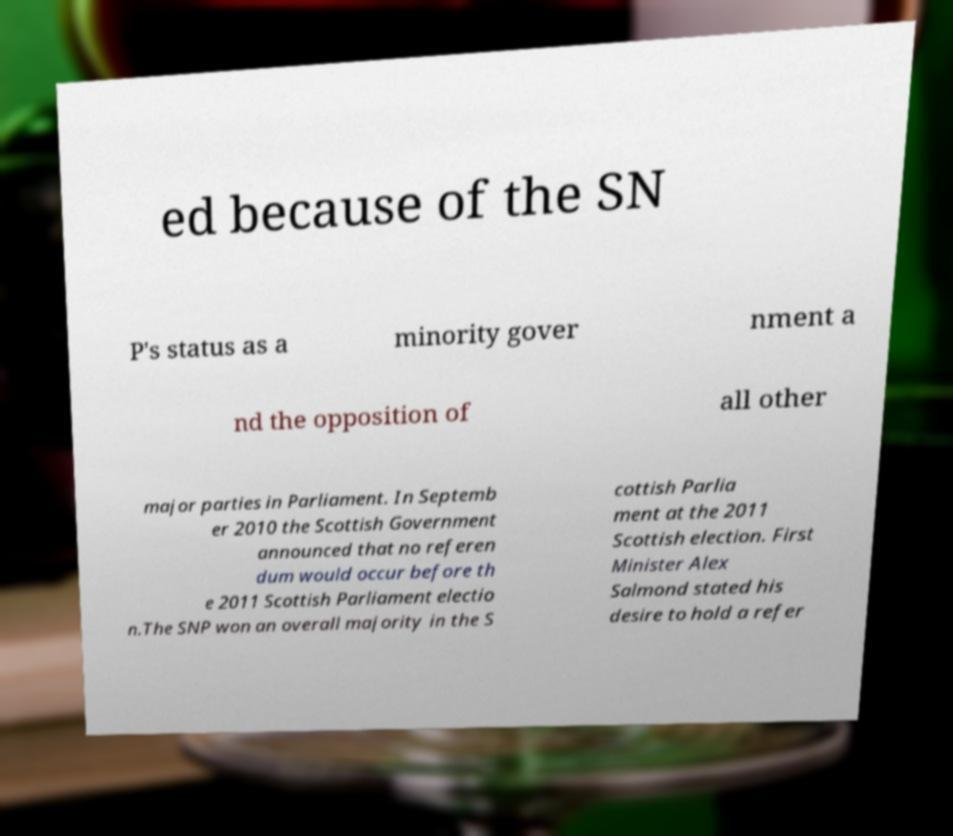Can you accurately transcribe the text from the provided image for me? ed because of the SN P's status as a minority gover nment a nd the opposition of all other major parties in Parliament. In Septemb er 2010 the Scottish Government announced that no referen dum would occur before th e 2011 Scottish Parliament electio n.The SNP won an overall majority in the S cottish Parlia ment at the 2011 Scottish election. First Minister Alex Salmond stated his desire to hold a refer 